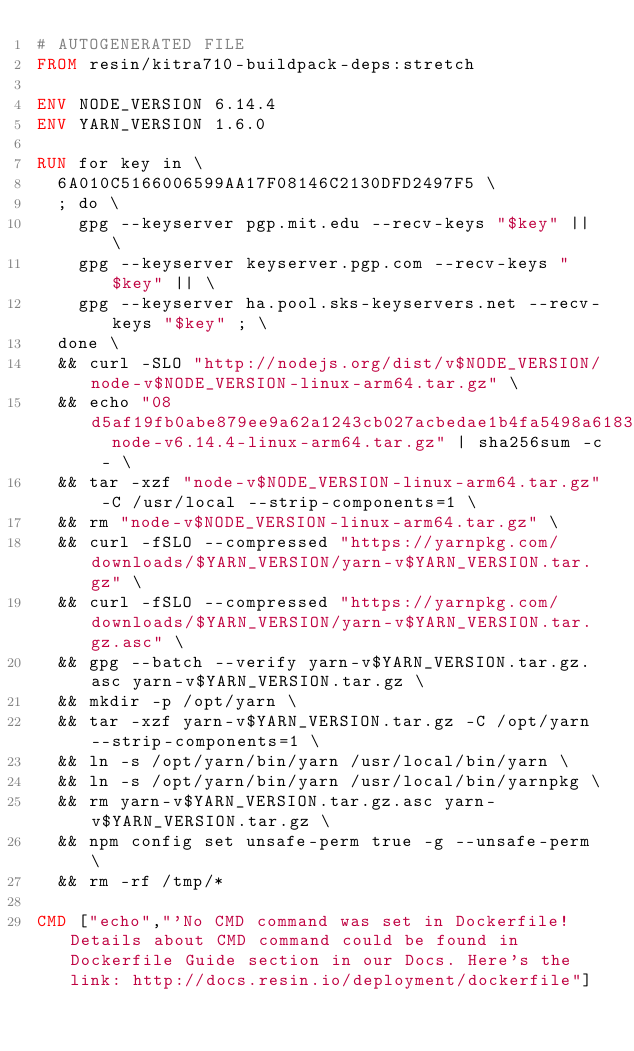<code> <loc_0><loc_0><loc_500><loc_500><_Dockerfile_># AUTOGENERATED FILE
FROM resin/kitra710-buildpack-deps:stretch

ENV NODE_VERSION 6.14.4
ENV YARN_VERSION 1.6.0

RUN for key in \
	6A010C5166006599AA17F08146C2130DFD2497F5 \
	; do \
		gpg --keyserver pgp.mit.edu --recv-keys "$key" || \
		gpg --keyserver keyserver.pgp.com --recv-keys "$key" || \
		gpg --keyserver ha.pool.sks-keyservers.net --recv-keys "$key" ; \
	done \
	&& curl -SLO "http://nodejs.org/dist/v$NODE_VERSION/node-v$NODE_VERSION-linux-arm64.tar.gz" \
	&& echo "08d5af19fb0abe879ee9a62a1243cb027acbedae1b4fa5498a6183cc458773ee  node-v6.14.4-linux-arm64.tar.gz" | sha256sum -c - \
	&& tar -xzf "node-v$NODE_VERSION-linux-arm64.tar.gz" -C /usr/local --strip-components=1 \
	&& rm "node-v$NODE_VERSION-linux-arm64.tar.gz" \
	&& curl -fSLO --compressed "https://yarnpkg.com/downloads/$YARN_VERSION/yarn-v$YARN_VERSION.tar.gz" \
	&& curl -fSLO --compressed "https://yarnpkg.com/downloads/$YARN_VERSION/yarn-v$YARN_VERSION.tar.gz.asc" \
	&& gpg --batch --verify yarn-v$YARN_VERSION.tar.gz.asc yarn-v$YARN_VERSION.tar.gz \
	&& mkdir -p /opt/yarn \
	&& tar -xzf yarn-v$YARN_VERSION.tar.gz -C /opt/yarn --strip-components=1 \
	&& ln -s /opt/yarn/bin/yarn /usr/local/bin/yarn \
	&& ln -s /opt/yarn/bin/yarn /usr/local/bin/yarnpkg \
	&& rm yarn-v$YARN_VERSION.tar.gz.asc yarn-v$YARN_VERSION.tar.gz \
	&& npm config set unsafe-perm true -g --unsafe-perm \
	&& rm -rf /tmp/*

CMD ["echo","'No CMD command was set in Dockerfile! Details about CMD command could be found in Dockerfile Guide section in our Docs. Here's the link: http://docs.resin.io/deployment/dockerfile"]
</code> 